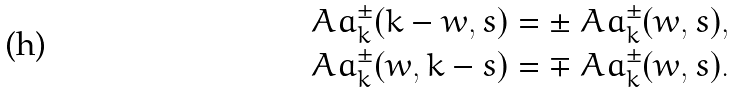<formula> <loc_0><loc_0><loc_500><loc_500>\ A a _ { k } ^ { \pm } ( k - w , s ) = \pm \ A a _ { k } ^ { \pm } ( w , s ) , \\ \ A a _ { k } ^ { \pm } ( w , k - s ) = \mp \ A a _ { k } ^ { \pm } ( w , s ) .</formula> 